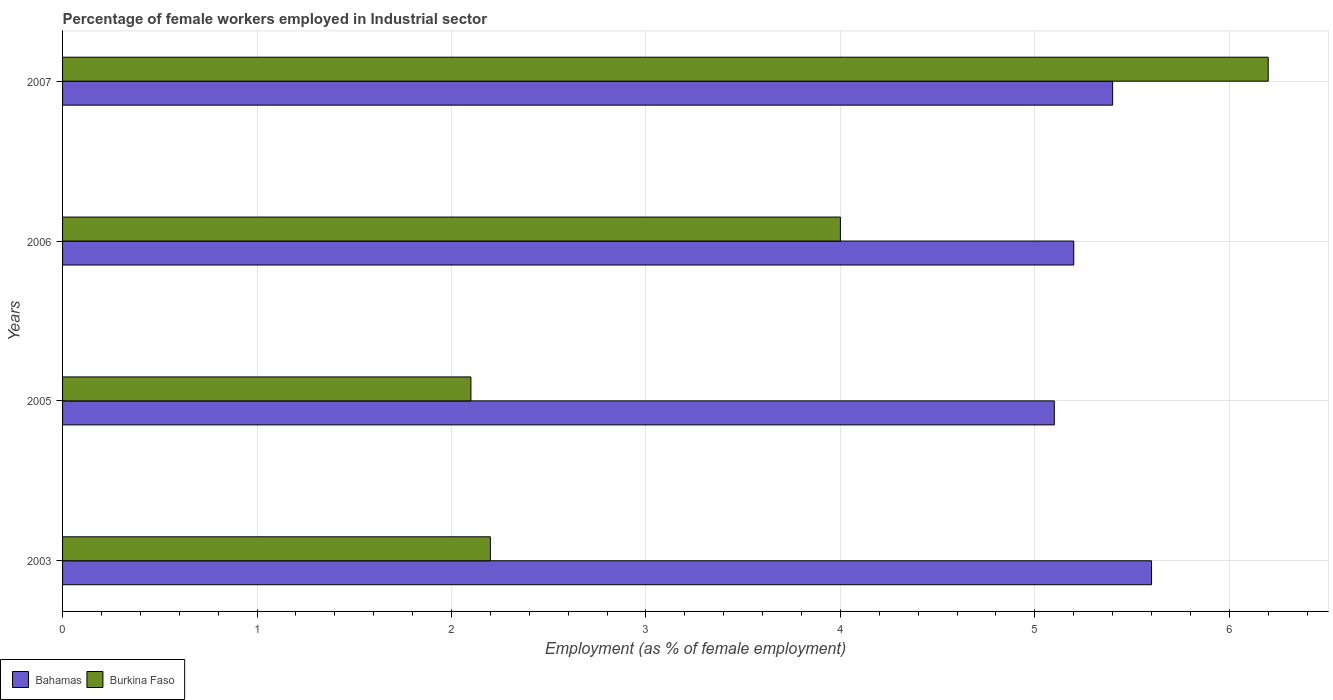How many different coloured bars are there?
Offer a terse response. 2. Are the number of bars per tick equal to the number of legend labels?
Give a very brief answer. Yes. Are the number of bars on each tick of the Y-axis equal?
Your response must be concise. Yes. What is the label of the 3rd group of bars from the top?
Provide a succinct answer. 2005. What is the percentage of females employed in Industrial sector in Burkina Faso in 2007?
Your answer should be very brief. 6.2. Across all years, what is the maximum percentage of females employed in Industrial sector in Burkina Faso?
Your response must be concise. 6.2. Across all years, what is the minimum percentage of females employed in Industrial sector in Burkina Faso?
Provide a short and direct response. 2.1. What is the total percentage of females employed in Industrial sector in Burkina Faso in the graph?
Give a very brief answer. 14.5. What is the difference between the percentage of females employed in Industrial sector in Bahamas in 2005 and that in 2006?
Keep it short and to the point. -0.1. What is the difference between the percentage of females employed in Industrial sector in Bahamas in 2006 and the percentage of females employed in Industrial sector in Burkina Faso in 2003?
Make the answer very short. 3. What is the average percentage of females employed in Industrial sector in Burkina Faso per year?
Provide a short and direct response. 3.62. In the year 2003, what is the difference between the percentage of females employed in Industrial sector in Bahamas and percentage of females employed in Industrial sector in Burkina Faso?
Ensure brevity in your answer.  3.4. What is the ratio of the percentage of females employed in Industrial sector in Bahamas in 2006 to that in 2007?
Provide a short and direct response. 0.96. What is the difference between the highest and the second highest percentage of females employed in Industrial sector in Bahamas?
Your answer should be compact. 0.2. What is the difference between the highest and the lowest percentage of females employed in Industrial sector in Burkina Faso?
Give a very brief answer. 4.1. In how many years, is the percentage of females employed in Industrial sector in Burkina Faso greater than the average percentage of females employed in Industrial sector in Burkina Faso taken over all years?
Your response must be concise. 2. What does the 1st bar from the top in 2003 represents?
Provide a succinct answer. Burkina Faso. What does the 2nd bar from the bottom in 2007 represents?
Your answer should be very brief. Burkina Faso. Does the graph contain any zero values?
Keep it short and to the point. No. Does the graph contain grids?
Give a very brief answer. Yes. Where does the legend appear in the graph?
Keep it short and to the point. Bottom left. How many legend labels are there?
Keep it short and to the point. 2. How are the legend labels stacked?
Your answer should be very brief. Horizontal. What is the title of the graph?
Your answer should be compact. Percentage of female workers employed in Industrial sector. What is the label or title of the X-axis?
Provide a short and direct response. Employment (as % of female employment). What is the label or title of the Y-axis?
Offer a terse response. Years. What is the Employment (as % of female employment) in Bahamas in 2003?
Provide a succinct answer. 5.6. What is the Employment (as % of female employment) in Burkina Faso in 2003?
Offer a terse response. 2.2. What is the Employment (as % of female employment) in Bahamas in 2005?
Offer a very short reply. 5.1. What is the Employment (as % of female employment) in Burkina Faso in 2005?
Provide a succinct answer. 2.1. What is the Employment (as % of female employment) of Bahamas in 2006?
Your answer should be very brief. 5.2. What is the Employment (as % of female employment) in Burkina Faso in 2006?
Your answer should be very brief. 4. What is the Employment (as % of female employment) in Bahamas in 2007?
Make the answer very short. 5.4. What is the Employment (as % of female employment) in Burkina Faso in 2007?
Your answer should be compact. 6.2. Across all years, what is the maximum Employment (as % of female employment) of Bahamas?
Make the answer very short. 5.6. Across all years, what is the maximum Employment (as % of female employment) of Burkina Faso?
Your response must be concise. 6.2. Across all years, what is the minimum Employment (as % of female employment) of Bahamas?
Provide a succinct answer. 5.1. Across all years, what is the minimum Employment (as % of female employment) of Burkina Faso?
Ensure brevity in your answer.  2.1. What is the total Employment (as % of female employment) of Bahamas in the graph?
Keep it short and to the point. 21.3. What is the difference between the Employment (as % of female employment) of Bahamas in 2003 and that in 2005?
Make the answer very short. 0.5. What is the difference between the Employment (as % of female employment) of Burkina Faso in 2003 and that in 2005?
Offer a terse response. 0.1. What is the difference between the Employment (as % of female employment) in Bahamas in 2003 and that in 2006?
Ensure brevity in your answer.  0.4. What is the difference between the Employment (as % of female employment) in Bahamas in 2003 and that in 2007?
Give a very brief answer. 0.2. What is the difference between the Employment (as % of female employment) in Bahamas in 2005 and that in 2007?
Make the answer very short. -0.3. What is the difference between the Employment (as % of female employment) of Bahamas in 2003 and the Employment (as % of female employment) of Burkina Faso in 2005?
Provide a succinct answer. 3.5. What is the difference between the Employment (as % of female employment) in Bahamas in 2005 and the Employment (as % of female employment) in Burkina Faso in 2006?
Offer a terse response. 1.1. What is the difference between the Employment (as % of female employment) in Bahamas in 2005 and the Employment (as % of female employment) in Burkina Faso in 2007?
Ensure brevity in your answer.  -1.1. What is the difference between the Employment (as % of female employment) in Bahamas in 2006 and the Employment (as % of female employment) in Burkina Faso in 2007?
Provide a short and direct response. -1. What is the average Employment (as % of female employment) in Bahamas per year?
Your answer should be very brief. 5.33. What is the average Employment (as % of female employment) of Burkina Faso per year?
Give a very brief answer. 3.62. In the year 2005, what is the difference between the Employment (as % of female employment) of Bahamas and Employment (as % of female employment) of Burkina Faso?
Your response must be concise. 3. In the year 2006, what is the difference between the Employment (as % of female employment) in Bahamas and Employment (as % of female employment) in Burkina Faso?
Provide a succinct answer. 1.2. What is the ratio of the Employment (as % of female employment) in Bahamas in 2003 to that in 2005?
Your response must be concise. 1.1. What is the ratio of the Employment (as % of female employment) in Burkina Faso in 2003 to that in 2005?
Your answer should be very brief. 1.05. What is the ratio of the Employment (as % of female employment) of Burkina Faso in 2003 to that in 2006?
Provide a short and direct response. 0.55. What is the ratio of the Employment (as % of female employment) in Bahamas in 2003 to that in 2007?
Your response must be concise. 1.04. What is the ratio of the Employment (as % of female employment) in Burkina Faso in 2003 to that in 2007?
Give a very brief answer. 0.35. What is the ratio of the Employment (as % of female employment) in Bahamas in 2005 to that in 2006?
Offer a very short reply. 0.98. What is the ratio of the Employment (as % of female employment) of Burkina Faso in 2005 to that in 2006?
Offer a terse response. 0.53. What is the ratio of the Employment (as % of female employment) of Bahamas in 2005 to that in 2007?
Ensure brevity in your answer.  0.94. What is the ratio of the Employment (as % of female employment) of Burkina Faso in 2005 to that in 2007?
Your answer should be very brief. 0.34. What is the ratio of the Employment (as % of female employment) in Bahamas in 2006 to that in 2007?
Your answer should be compact. 0.96. What is the ratio of the Employment (as % of female employment) of Burkina Faso in 2006 to that in 2007?
Provide a succinct answer. 0.65. What is the difference between the highest and the second highest Employment (as % of female employment) of Burkina Faso?
Your response must be concise. 2.2. What is the difference between the highest and the lowest Employment (as % of female employment) of Bahamas?
Provide a succinct answer. 0.5. 